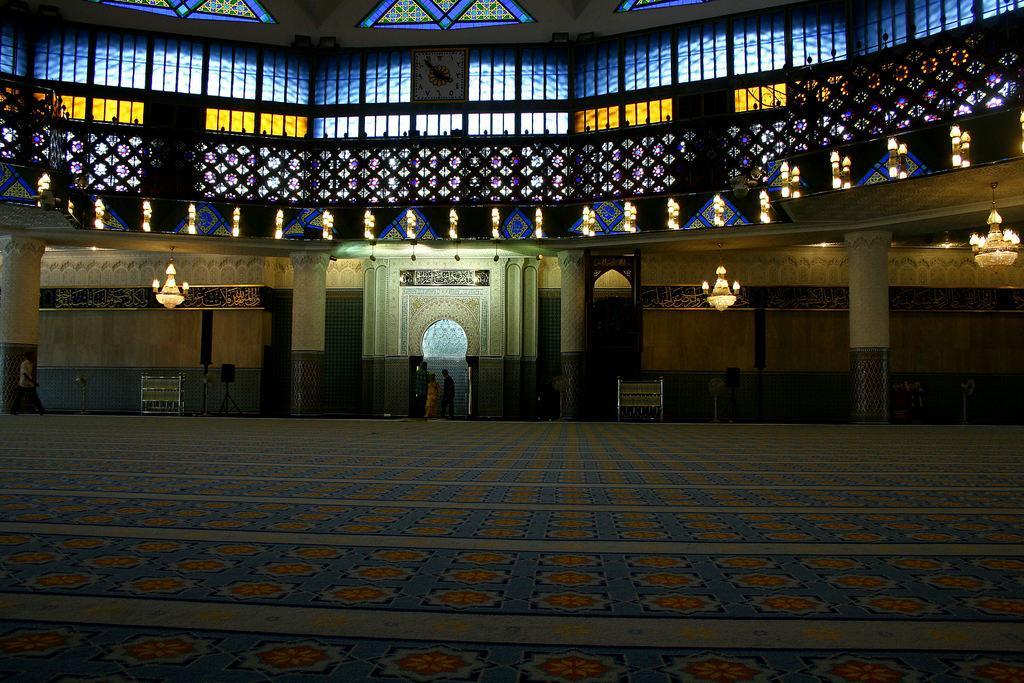Describe this image in one or two sentences. In this picture we can see few people, and we can find few chandelier lights, speakers, stained glasses and metal rods. 